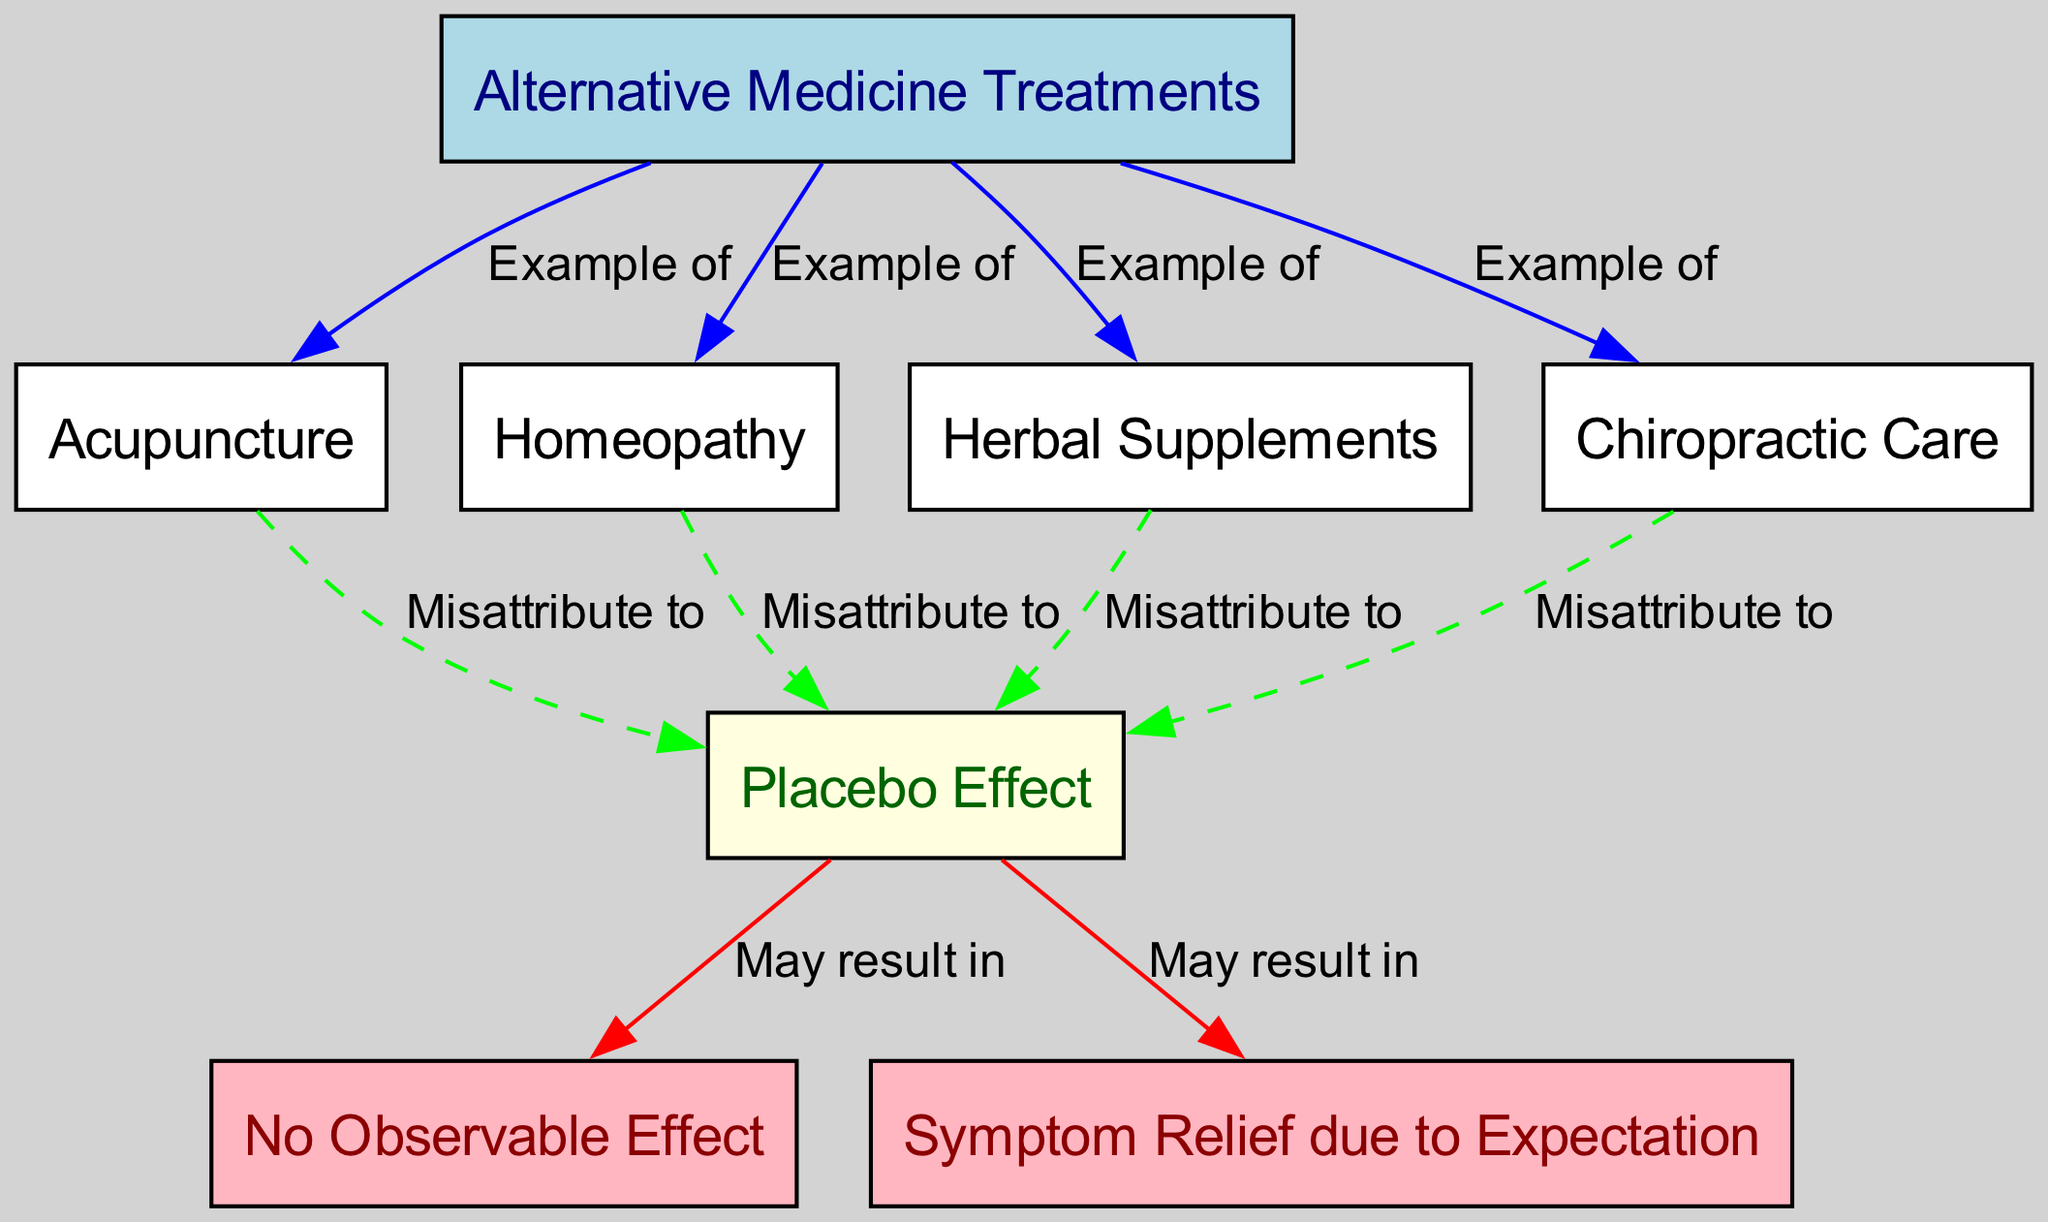What are examples of alternative medicine treatments? The diagram lists four examples of alternative medicine treatments, which are Acupuncture, Homeopathy, Herbal Supplements, and Chiropractic Care, all of which are connected to the "Alternative Medicine Treatments" node.
Answer: Acupuncture, Homeopathy, Herbal Supplements, Chiropractic Care How many nodes are present in the diagram? The diagram contains 8 nodes in total; these include types of alternative medicine, placebo, and resulting effects. By counting each node listed in the data, I confirm the total is indeed 8.
Answer: 8 What type of effect might be misattributed according to the diagram? The diagram suggests the "Placebo Effect" may lead to misattributions regarding "Acupuncture," "Homeopathy," "Herbal Supplements," and "Chiropractic Care," showing how the effects of these treatments can be mistakenly credited to them rather than to the placebo.
Answer: Placebo Effect What color represents 'Symptom Relief due to Expectation'? Referring to the diagram, the node labeled "Symptom Relief due to Expectation" is filled with light pink color. This choice of color visually sets it apart and indicates its connection to potentially misleading perceptions of treatment effectiveness.
Answer: Light pink What could the "Placebo Effect" potentially lead to? The diagram shows that the "Placebo Effect" may result in either "No Observable Effect" or "Symptom Relief due to Expectation," indicating both possible outcomes that stem from believing in the efficacy of the treatment. This highlights the dual nature of how placebo can influence perceived health outcomes.
Answer: No Observable Effect, Symptom Relief due to Expectation What relationship do "Acupuncture" and "Placebo Effect" have? According to the diagram, the relationship between "Acupuncture" and "Placebo Effect" is termed "Misattribute to," meaning that the benefits perceived from acupuncture can often be mistakenly attributed to its effects instead of recognizing that they might arise from placebo.
Answer: Misattribute to What does the "No Observable Effect" node connect to? The "No Observable Effect" node connects directly to the "Placebo Effect" node, indicating a potential outcome of treatments that do not yield measurable results despite the involvement of placebo responses. This shows a possible result that may be falsely identified as effective treatment.
Answer: Placebo Effect Which alternative treatment does the diagram show as an example of misattribution? The diagram shows all alternative treatments listed: "Acupuncture," "Homeopathy," "Herbal Supplements," and "Chiropractic Care" can be misattributed to the "Placebo Effect." This indicates that the perceived effects of these treatments might revert to unintended influences from placebo responses.
Answer: Acupuncture, Homeopathy, Herbal Supplements, Chiropractic Care 